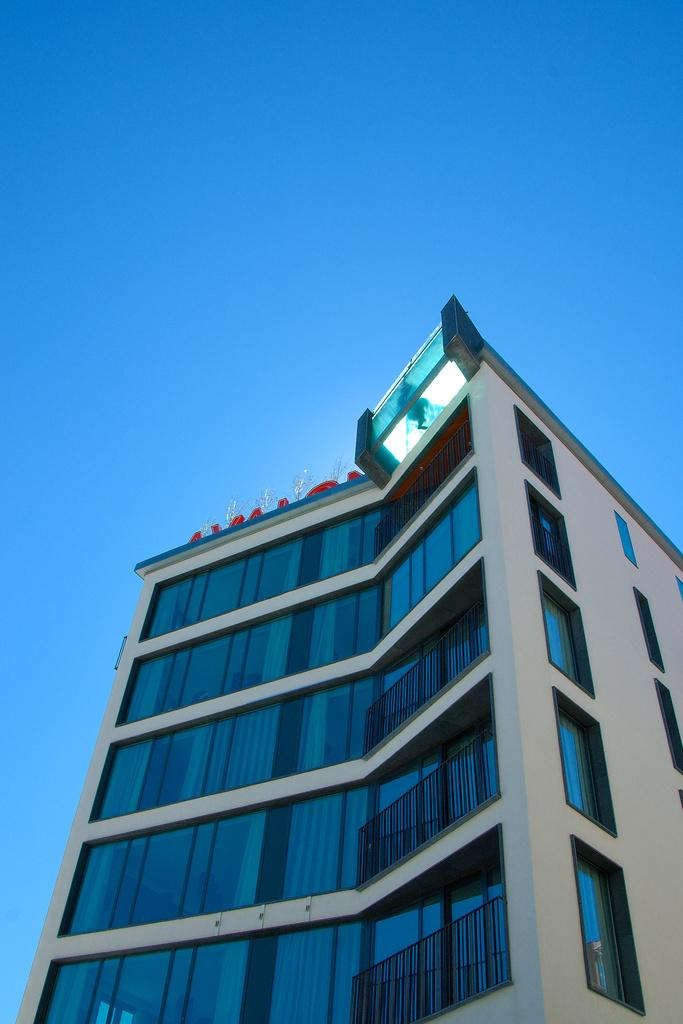What is the main structure in the image? There is a building in the image. Are there any objects on top of the building? Yes, there are objects on top of the building. What can be seen in the background of the image? The sky is visible in the image. What type of haircut is the building getting in the image? There is no haircut being performed on the building in the image. Can you see any notebooks on the building in the image? There are no notebooks visible on the building in the image. 